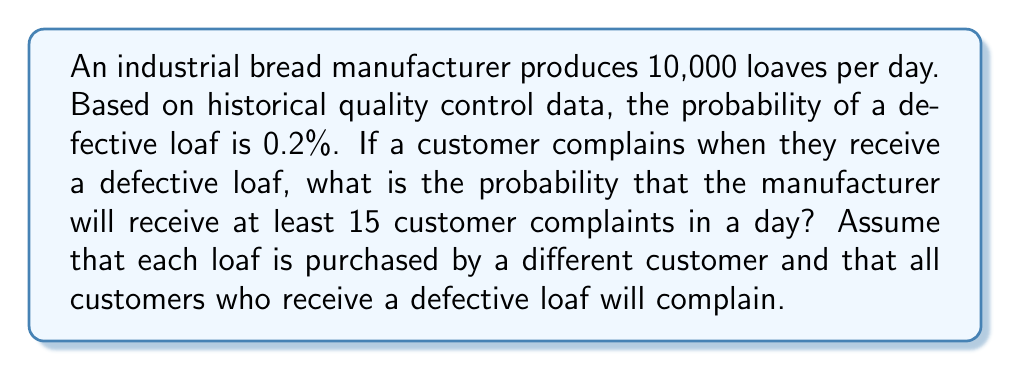What is the answer to this math problem? To solve this problem, we'll use the Poisson distribution, which is suitable for modeling rare events over a fixed interval. Let's break it down step-by-step:

1) First, we need to calculate the expected number of defective loaves per day:
   $\lambda = 10,000 \times 0.002 = 20$

2) We assume that each defective loaf results in a complaint, so $\lambda$ is also the expected number of complaints per day.

3) We want to find the probability of at least 15 complaints, which is equivalent to 1 minus the probability of 14 or fewer complaints.

4) The Poisson probability mass function is:

   $$P(X = k) = \frac{e^{-\lambda}\lambda^k}{k!}$$

   where $X$ is the number of events, $k$ is the specific number we're interested in, and $\lambda$ is the expected number of events.

5) We need to calculate:

   $$P(X \geq 15) = 1 - P(X \leq 14) = 1 - \sum_{k=0}^{14} \frac{e^{-20}20^k}{k!}$$

6) This sum is difficult to calculate by hand, so we would typically use statistical software or a calculator with this function built-in. 

7) Using such a tool, we find that:

   $$\sum_{k=0}^{14} \frac{e^{-20}20^k}{k!} \approx 0.1071$$

8) Therefore, the probability of at least 15 complaints is:

   $$P(X \geq 15) = 1 - 0.1071 = 0.8929$$
Answer: The probability that the manufacturer will receive at least 15 customer complaints in a day is approximately 0.8929 or 89.29%. 